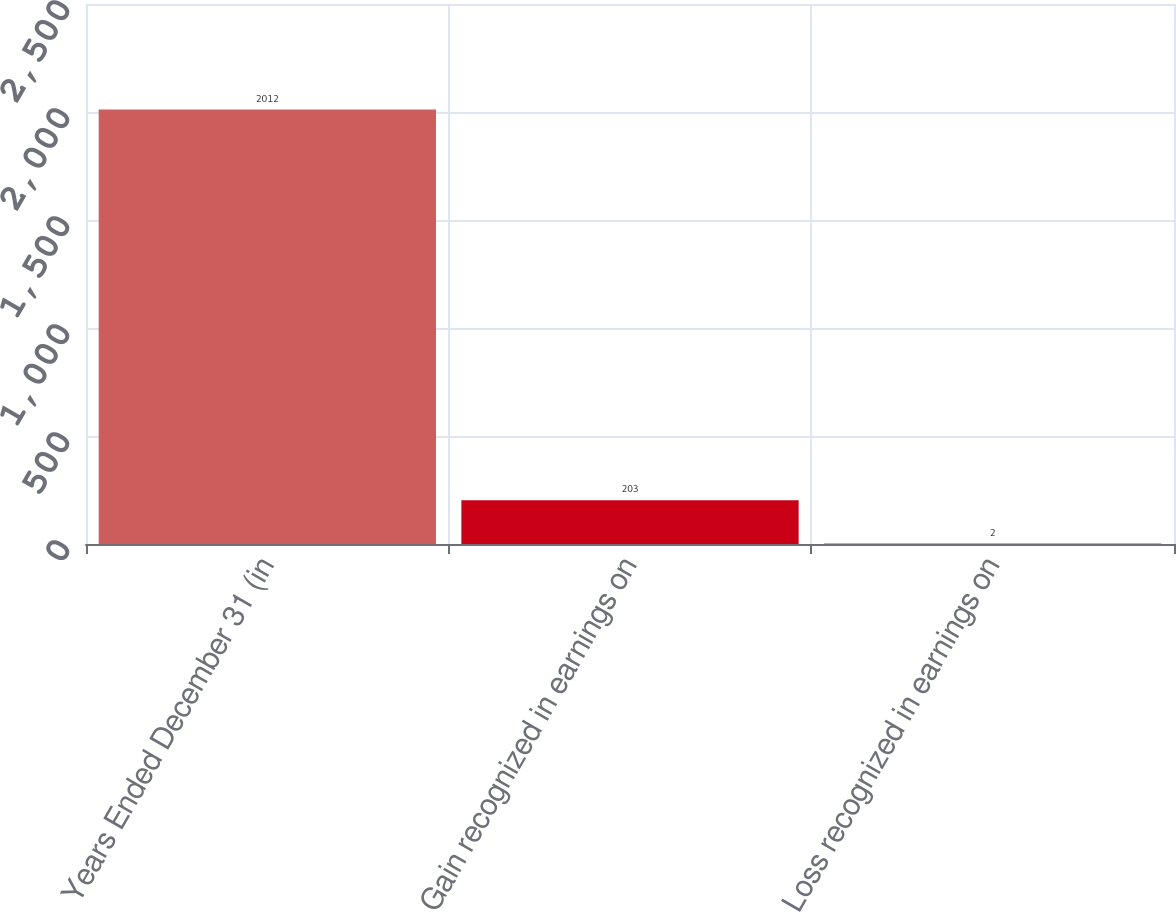Convert chart. <chart><loc_0><loc_0><loc_500><loc_500><bar_chart><fcel>Years Ended December 31 (in<fcel>Gain recognized in earnings on<fcel>Loss recognized in earnings on<nl><fcel>2012<fcel>203<fcel>2<nl></chart> 